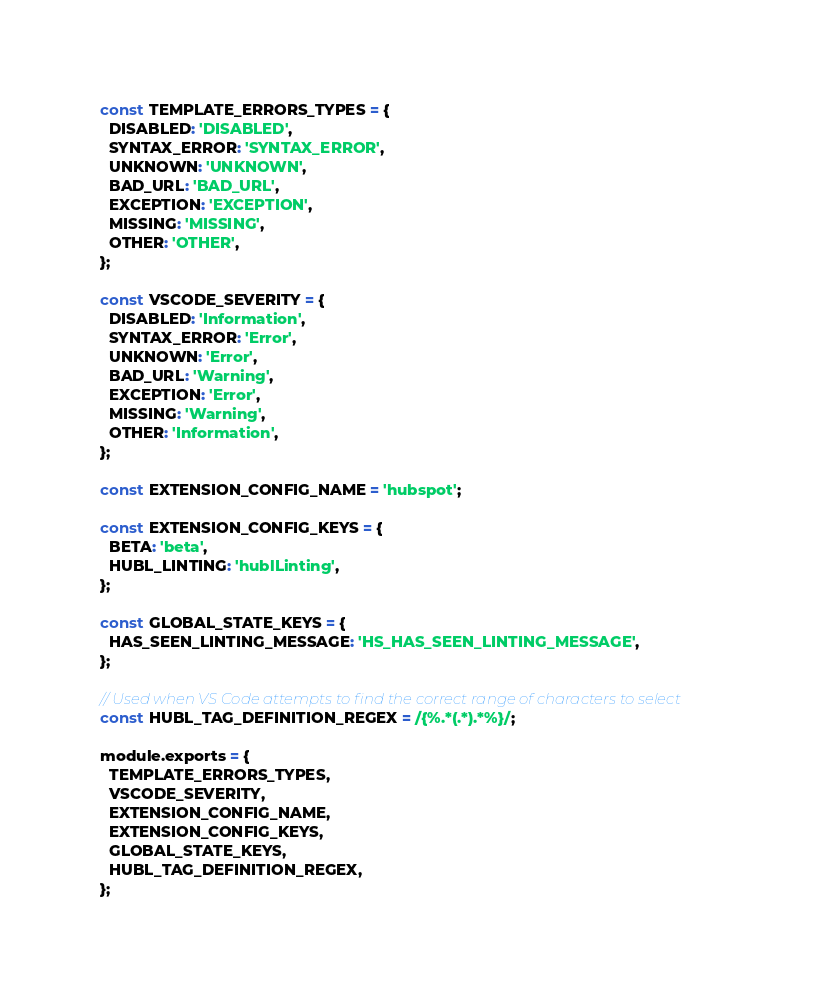<code> <loc_0><loc_0><loc_500><loc_500><_JavaScript_>const TEMPLATE_ERRORS_TYPES = {
  DISABLED: 'DISABLED',
  SYNTAX_ERROR: 'SYNTAX_ERROR',
  UNKNOWN: 'UNKNOWN',
  BAD_URL: 'BAD_URL',
  EXCEPTION: 'EXCEPTION',
  MISSING: 'MISSING',
  OTHER: 'OTHER',
};

const VSCODE_SEVERITY = {
  DISABLED: 'Information',
  SYNTAX_ERROR: 'Error',
  UNKNOWN: 'Error',
  BAD_URL: 'Warning',
  EXCEPTION: 'Error',
  MISSING: 'Warning',
  OTHER: 'Information',
};

const EXTENSION_CONFIG_NAME = 'hubspot';

const EXTENSION_CONFIG_KEYS = {
  BETA: 'beta',
  HUBL_LINTING: 'hublLinting',
};

const GLOBAL_STATE_KEYS = {
  HAS_SEEN_LINTING_MESSAGE: 'HS_HAS_SEEN_LINTING_MESSAGE',
};

// Used when VS Code attempts to find the correct range of characters to select
const HUBL_TAG_DEFINITION_REGEX = /{%.*(.*).*%}/;

module.exports = {
  TEMPLATE_ERRORS_TYPES,
  VSCODE_SEVERITY,
  EXTENSION_CONFIG_NAME,
  EXTENSION_CONFIG_KEYS,
  GLOBAL_STATE_KEYS,
  HUBL_TAG_DEFINITION_REGEX,
};
</code> 